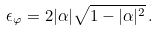<formula> <loc_0><loc_0><loc_500><loc_500>\epsilon _ { \varphi } = 2 | \alpha | \sqrt { 1 - | \alpha | ^ { 2 } } \, .</formula> 